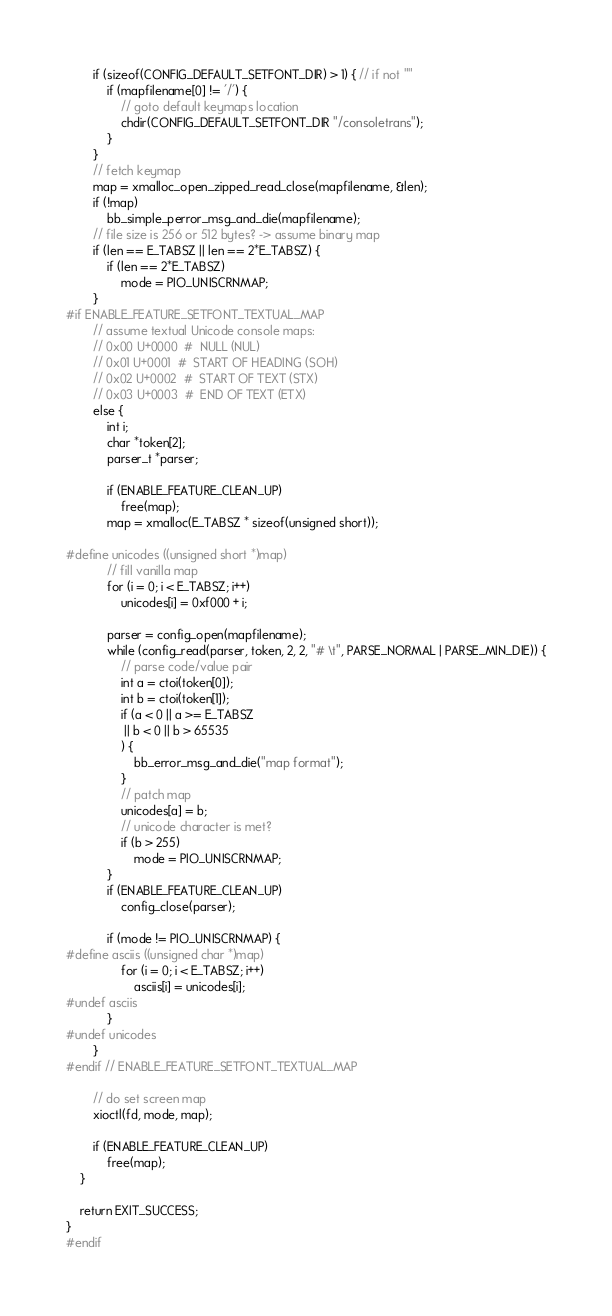<code> <loc_0><loc_0><loc_500><loc_500><_C_>
		if (sizeof(CONFIG_DEFAULT_SETFONT_DIR) > 1) { // if not ""
			if (mapfilename[0] != '/') {
				// goto default keymaps location
				chdir(CONFIG_DEFAULT_SETFONT_DIR "/consoletrans");
			}
		}
		// fetch keymap
		map = xmalloc_open_zipped_read_close(mapfilename, &len);
		if (!map)
			bb_simple_perror_msg_and_die(mapfilename);
		// file size is 256 or 512 bytes? -> assume binary map
		if (len == E_TABSZ || len == 2*E_TABSZ) {
			if (len == 2*E_TABSZ)
				mode = PIO_UNISCRNMAP;
		}
#if ENABLE_FEATURE_SETFONT_TEXTUAL_MAP
		// assume textual Unicode console maps:
		// 0x00 U+0000  #  NULL (NUL)
		// 0x01 U+0001  #  START OF HEADING (SOH)
		// 0x02 U+0002  #  START OF TEXT (STX)
		// 0x03 U+0003  #  END OF TEXT (ETX)
		else {
			int i;
			char *token[2];
			parser_t *parser;

			if (ENABLE_FEATURE_CLEAN_UP)
				free(map);
			map = xmalloc(E_TABSZ * sizeof(unsigned short));

#define unicodes ((unsigned short *)map)
			// fill vanilla map
			for (i = 0; i < E_TABSZ; i++)
				unicodes[i] = 0xf000 + i;

			parser = config_open(mapfilename);
			while (config_read(parser, token, 2, 2, "# \t", PARSE_NORMAL | PARSE_MIN_DIE)) {
				// parse code/value pair
				int a = ctoi(token[0]);
				int b = ctoi(token[1]);
				if (a < 0 || a >= E_TABSZ
				 || b < 0 || b > 65535
				) {
					bb_error_msg_and_die("map format");
				}
				// patch map
				unicodes[a] = b;
				// unicode character is met?
				if (b > 255)
					mode = PIO_UNISCRNMAP;
			}
			if (ENABLE_FEATURE_CLEAN_UP)
				config_close(parser);

			if (mode != PIO_UNISCRNMAP) {
#define asciis ((unsigned char *)map)
				for (i = 0; i < E_TABSZ; i++)
					asciis[i] = unicodes[i];
#undef asciis
			}
#undef unicodes
		}
#endif // ENABLE_FEATURE_SETFONT_TEXTUAL_MAP

		// do set screen map
		xioctl(fd, mode, map);

		if (ENABLE_FEATURE_CLEAN_UP)
			free(map);
	}

	return EXIT_SUCCESS;
}
#endif
</code> 